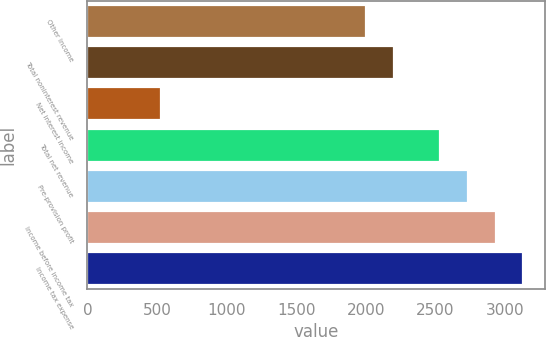<chart> <loc_0><loc_0><loc_500><loc_500><bar_chart><fcel>Other income<fcel>Total noninterest revenue<fcel>Net interest income<fcel>Total net revenue<fcel>Pre-provision profit<fcel>Income before income tax<fcel>Income tax expense<nl><fcel>2003<fcel>2203.3<fcel>530<fcel>2533<fcel>2733.3<fcel>2933.6<fcel>3133.9<nl></chart> 